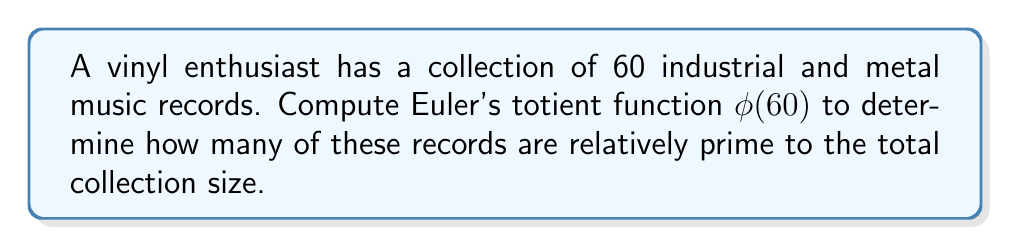Teach me how to tackle this problem. To compute Euler's totient function $\phi(60)$, we follow these steps:

1) First, let's factor 60 into its prime factors:
   $60 = 2^2 \times 3 \times 5$

2) The formula for Euler's totient function is:
   $$\phi(n) = n \prod_{p|n} (1 - \frac{1}{p})$$
   where $p$ are the distinct prime factors of $n$.

3) For 60, we have:
   $$\phi(60) = 60 \times (1 - \frac{1}{2}) \times (1 - \frac{1}{3}) \times (1 - \frac{1}{5})$$

4) Let's calculate each part:
   $60 \times \frac{1}{2} \times \frac{2}{3} \times \frac{4}{5}$

5) Simplifying:
   $60 \times \frac{4}{30} = 8$

Therefore, there are 8 records in the collection that are relatively prime to 60.
Answer: $\phi(60) = 16$ 